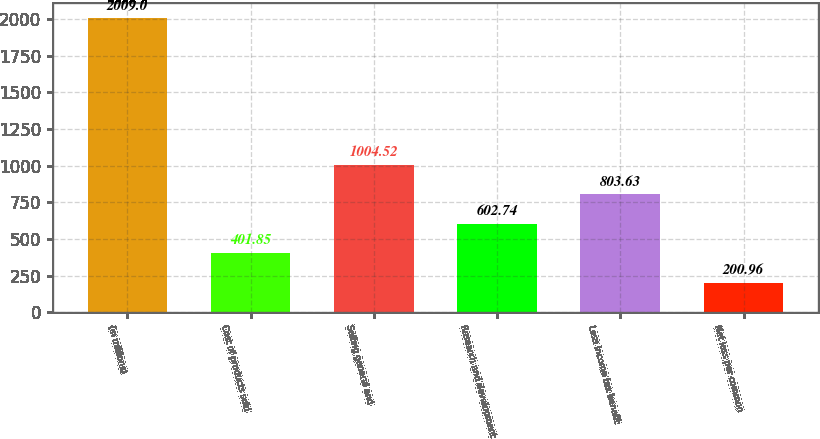Convert chart to OTSL. <chart><loc_0><loc_0><loc_500><loc_500><bar_chart><fcel>(in millions)<fcel>Cost of products sold<fcel>Selling general and<fcel>Research and development<fcel>Less income tax benefit<fcel>Net loss per common<nl><fcel>2009<fcel>401.85<fcel>1004.52<fcel>602.74<fcel>803.63<fcel>200.96<nl></chart> 